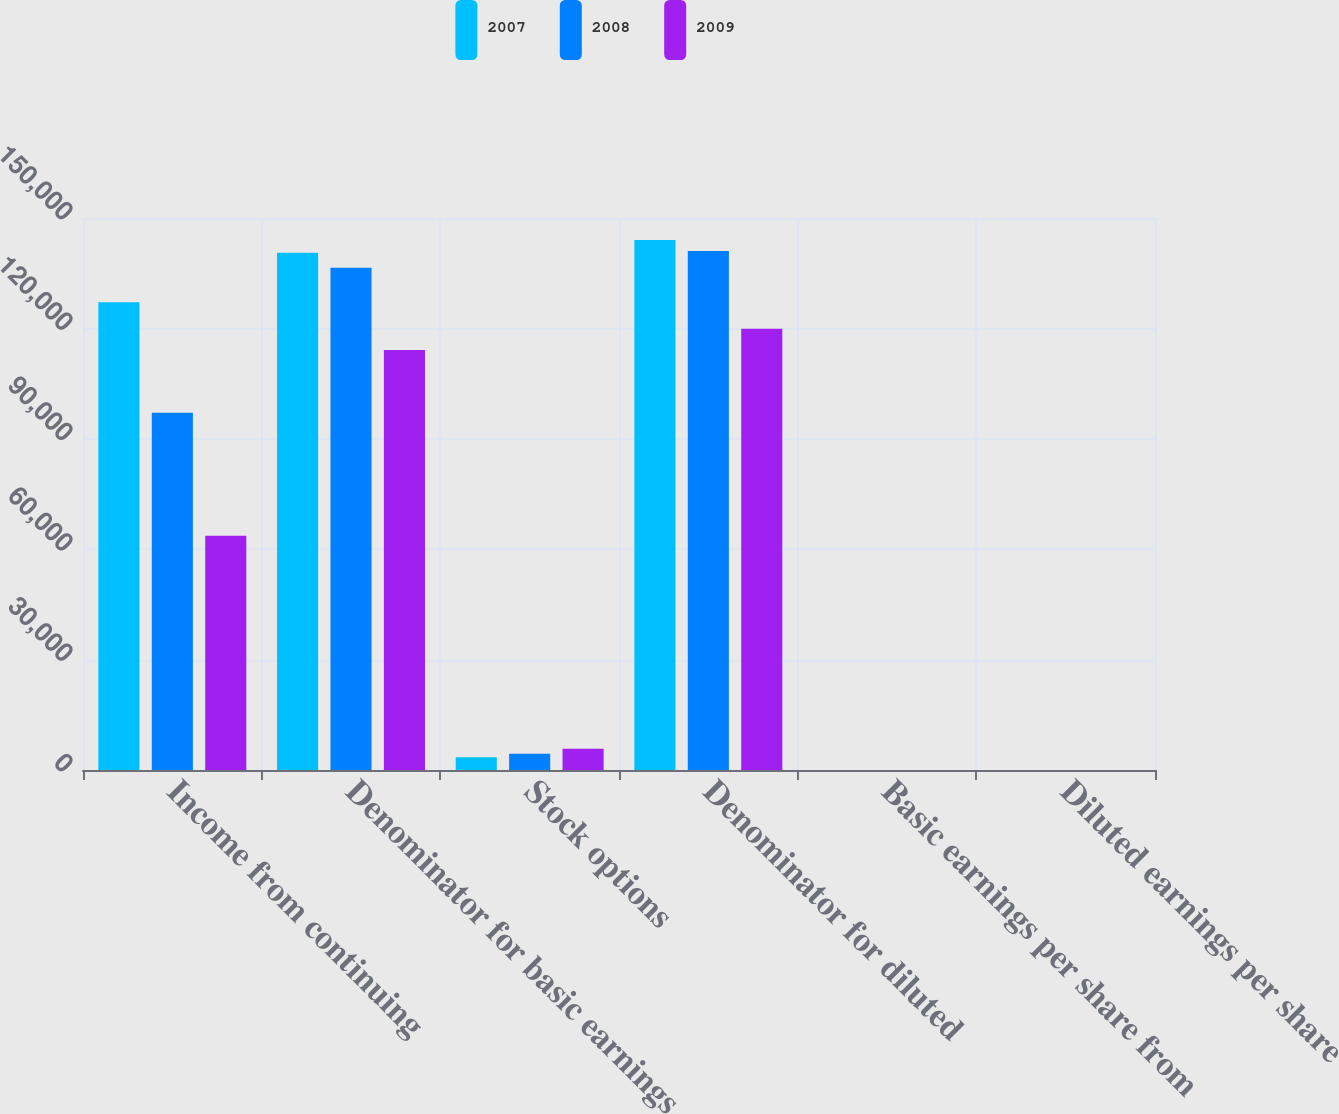Convert chart. <chart><loc_0><loc_0><loc_500><loc_500><stacked_bar_chart><ecel><fcel>Income from continuing<fcel>Denominator for basic earnings<fcel>Stock options<fcel>Denominator for diluted<fcel>Basic earnings per share from<fcel>Diluted earnings per share<nl><fcel>2007<fcel>127137<fcel>140541<fcel>3438<fcel>143990<fcel>0.9<fcel>0.88<nl><fcel>2008<fcel>97092<fcel>136488<fcel>4426<fcel>141023<fcel>0.71<fcel>0.69<nl><fcel>2009<fcel>63622<fcel>114161<fcel>5776<fcel>119937<fcel>0.56<fcel>0.53<nl></chart> 